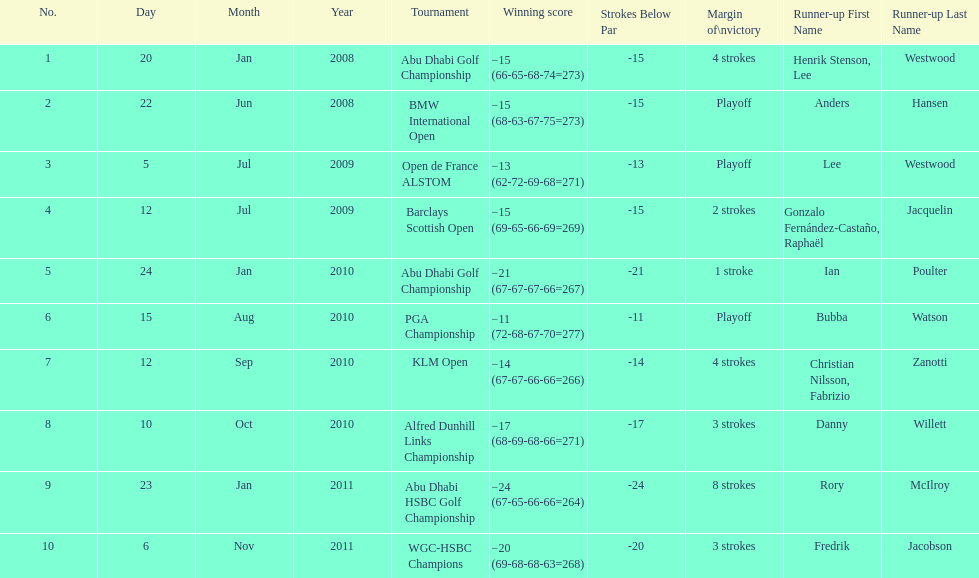I'm looking to parse the entire table for insights. Could you assist me with that? {'header': ['No.', 'Day', 'Month', 'Year', 'Tournament', 'Winning score', 'Strokes Below Par', 'Margin of\\nvictory', 'Runner-up First Name', 'Runner-up Last Name'], 'rows': [['1', '20', 'Jan', '2008', 'Abu Dhabi Golf Championship', '−15 (66-65-68-74=273)', '-15', '4 strokes', 'Henrik Stenson, Lee', 'Westwood'], ['2', '22', 'Jun', '2008', 'BMW International Open', '−15 (68-63-67-75=273)', '-15', 'Playoff', 'Anders', 'Hansen'], ['3', '5', 'Jul', '2009', 'Open de France ALSTOM', '−13 (62-72-69-68=271)', '-13', 'Playoff', 'Lee', 'Westwood'], ['4', '12', 'Jul', '2009', 'Barclays Scottish Open', '−15 (69-65-66-69=269)', '-15', '2 strokes', 'Gonzalo Fernández-Castaño, Raphaël', 'Jacquelin'], ['5', '24', 'Jan', '2010', 'Abu Dhabi Golf Championship', '−21 (67-67-67-66=267)', '-21', '1 stroke', 'Ian', 'Poulter'], ['6', '15', 'Aug', '2010', 'PGA Championship', '−11 (72-68-67-70=277)', '-11', 'Playoff', 'Bubba', 'Watson'], ['7', '12', 'Sep', '2010', 'KLM Open', '−14 (67-67-66-66=266)', '-14', '4 strokes', 'Christian Nilsson, Fabrizio', 'Zanotti'], ['8', '10', 'Oct', '2010', 'Alfred Dunhill Links Championship', '−17 (68-69-68-66=271)', '-17', '3 strokes', 'Danny', 'Willett'], ['9', '23', 'Jan', '2011', 'Abu Dhabi HSBC Golf Championship', '−24 (67-65-66-66=264)', '-24', '8 strokes', 'Rory', 'McIlroy'], ['10', '6', 'Nov', '2011', 'WGC-HSBC Champions', '−20 (69-68-68-63=268)', '-20', '3 strokes', 'Fredrik', 'Jacobson']]} How long separated the playoff victory at bmw international open and the 4 stroke victory at the klm open? 2 years. 